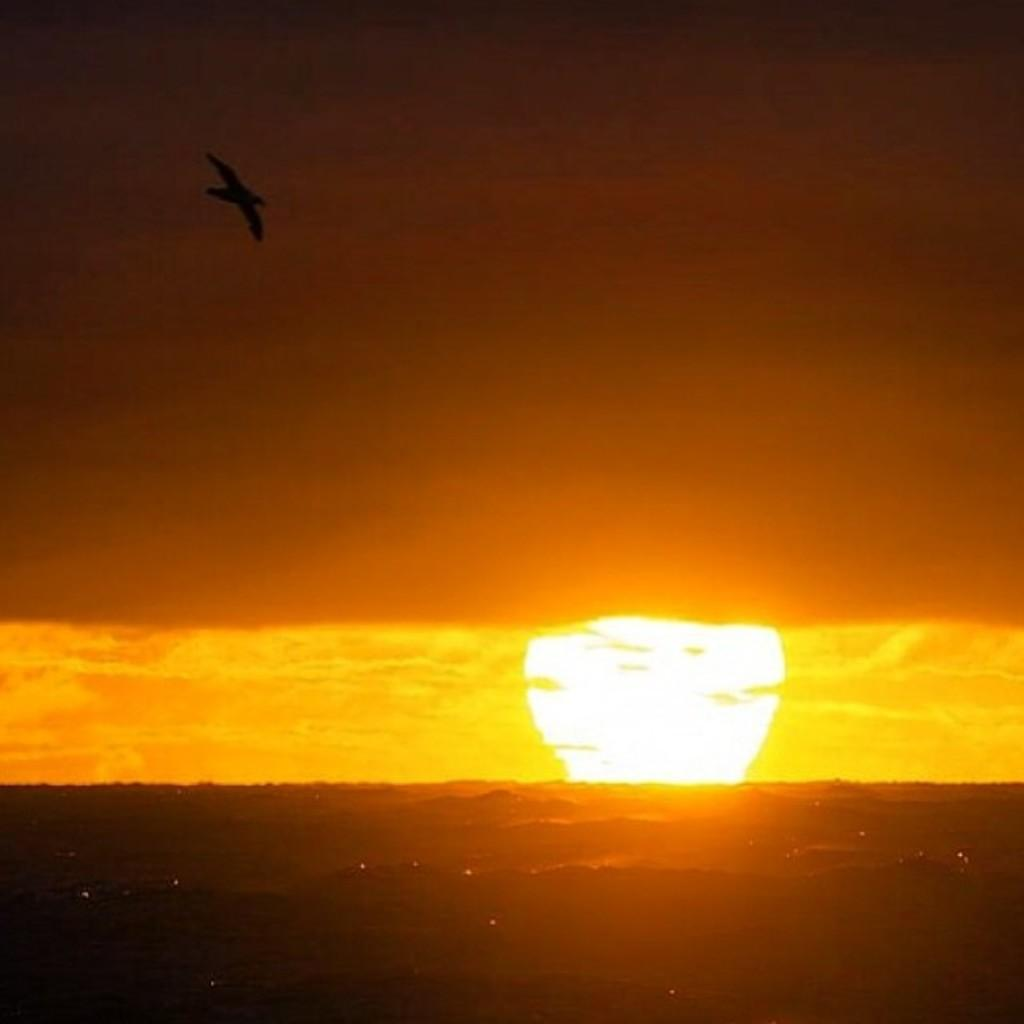What type of animal can be seen in the image? There is a bird in the image. What is the bird doing in the image? The bird is flying in the sky. What can be seen in the background of the image? There is sun visible in the background of the image. What type of rod is the bird holding in the image? There is no rod present in the image; the bird is simply flying. 